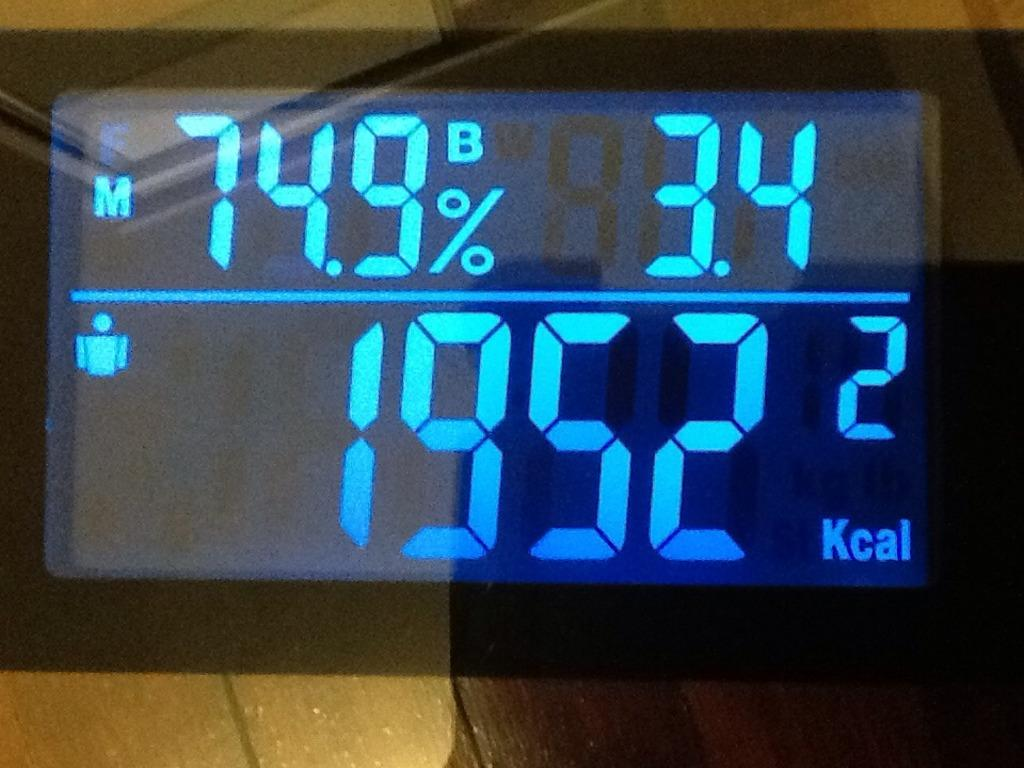<image>
Summarize the visual content of the image. An electronic display that shows that the person has burned 1952 Kcal. 